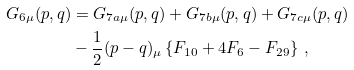Convert formula to latex. <formula><loc_0><loc_0><loc_500><loc_500>G _ { 6 \mu } ( p , q ) & = G _ { 7 a \mu } ( p , q ) + G _ { 7 b \mu } ( p , q ) + G _ { 7 c \mu } ( p , q ) \\ & - \frac { 1 } { 2 } ( p - q ) _ { \mu } \left \{ F _ { 1 0 } + 4 F _ { 6 } - F _ { 2 9 } \right \} \, ,</formula> 